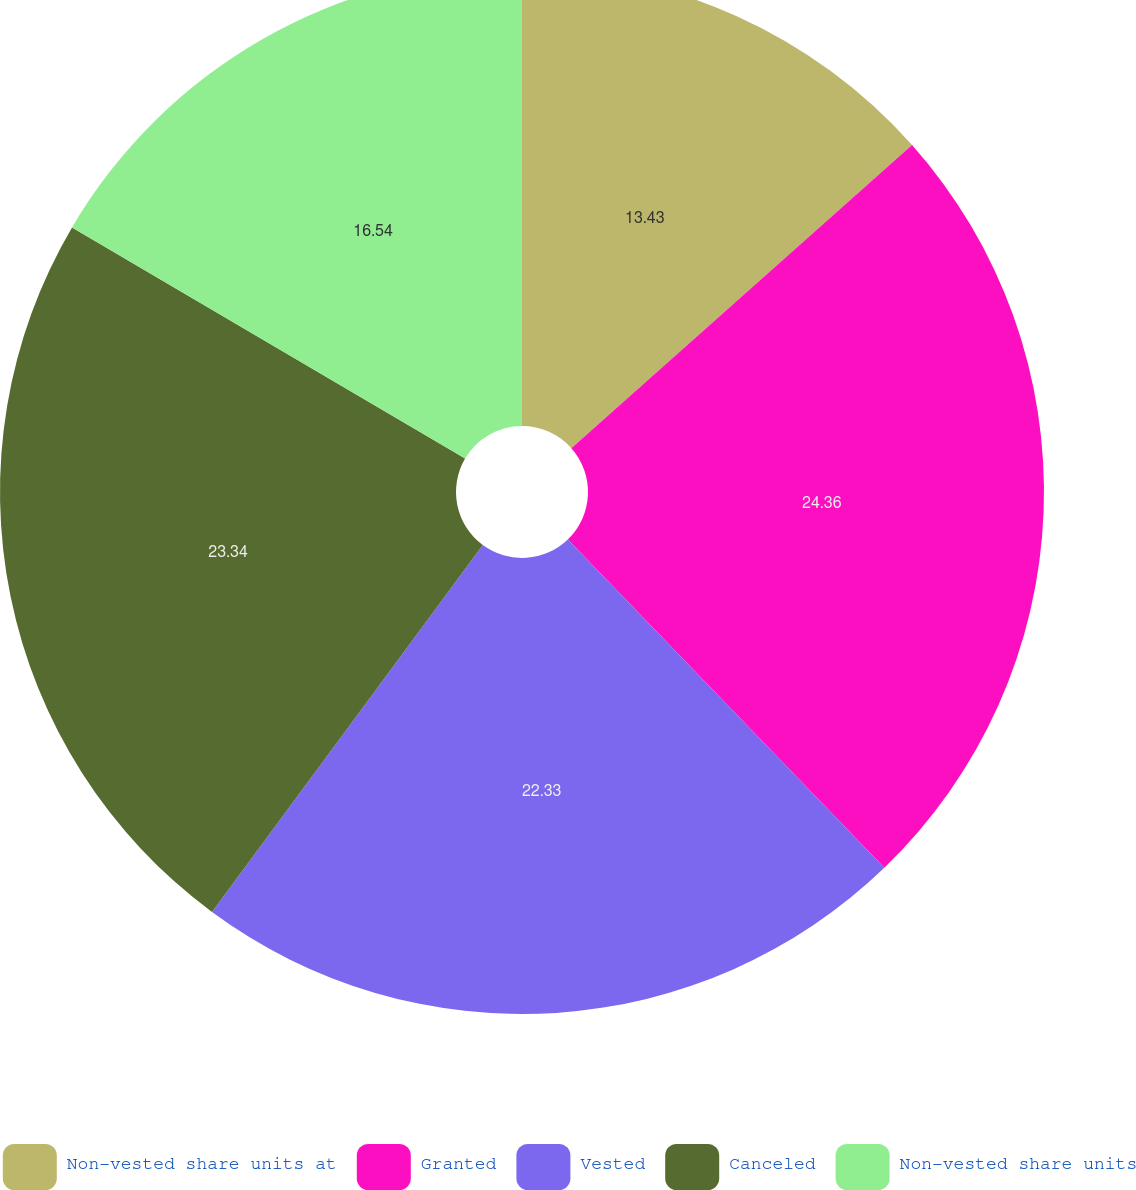Convert chart. <chart><loc_0><loc_0><loc_500><loc_500><pie_chart><fcel>Non-vested share units at<fcel>Granted<fcel>Vested<fcel>Canceled<fcel>Non-vested share units<nl><fcel>13.43%<fcel>24.36%<fcel>22.33%<fcel>23.34%<fcel>16.54%<nl></chart> 